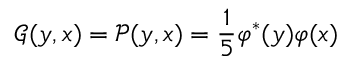Convert formula to latex. <formula><loc_0><loc_0><loc_500><loc_500>\mathcal { G } ( y , x ) = \mathcal { P } ( y , x ) = \frac { 1 } { 5 } \varphi ^ { * } ( y ) \varphi ( x )</formula> 